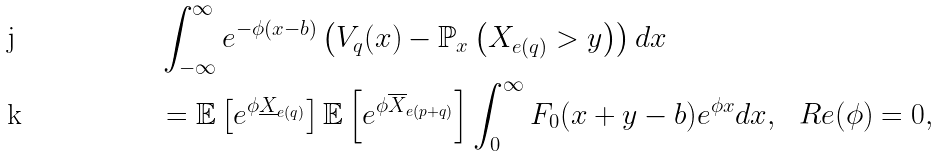<formula> <loc_0><loc_0><loc_500><loc_500>& \int _ { - \infty } ^ { \infty } e ^ { - \phi ( x - b ) } \left ( V _ { q } ( x ) - \mathbb { P } _ { x } \left ( X _ { e ( q ) } > y \right ) \right ) d x \\ & = \mathbb { E } \left [ e ^ { \phi \underline { X } _ { e ( q ) } } \right ] \mathbb { E } \left [ e ^ { \phi \overline { X } _ { e ( p + q ) } } \right ] \int _ { 0 } ^ { \infty } F _ { 0 } ( x + y - b ) e ^ { \phi x } d x , \ \ R e ( \phi ) = 0 ,</formula> 